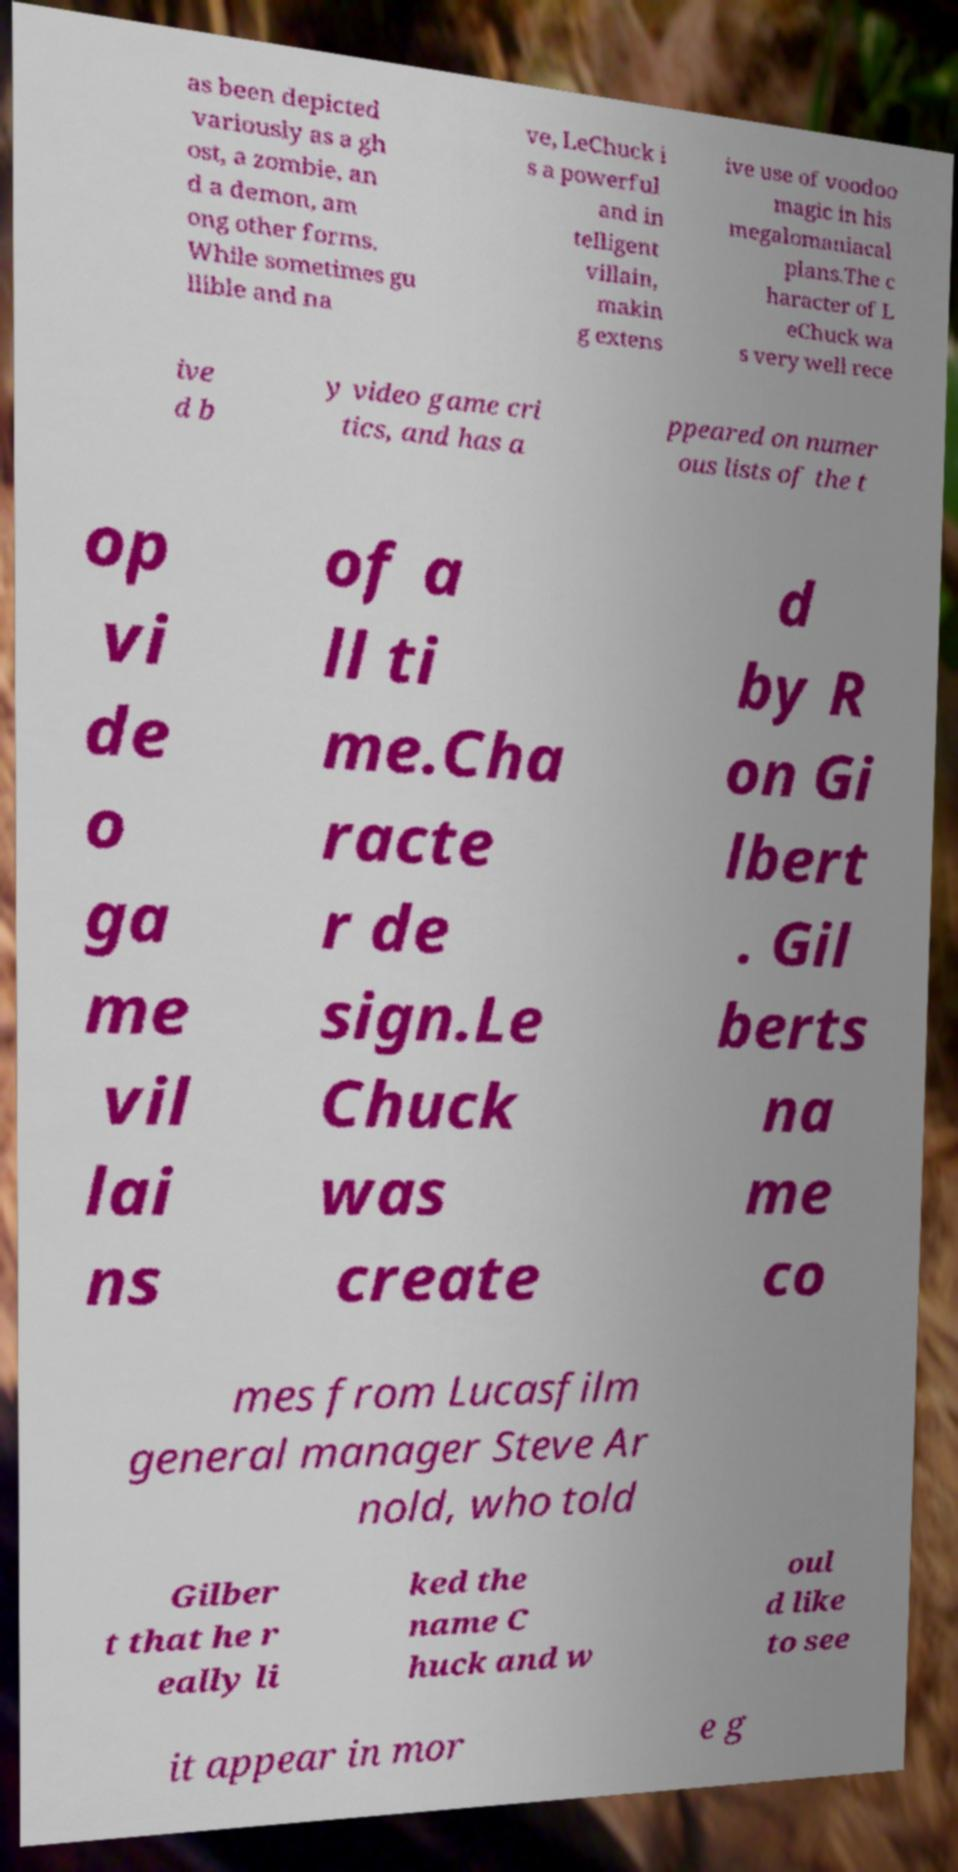There's text embedded in this image that I need extracted. Can you transcribe it verbatim? as been depicted variously as a gh ost, a zombie, an d a demon, am ong other forms. While sometimes gu llible and na ve, LeChuck i s a powerful and in telligent villain, makin g extens ive use of voodoo magic in his megalomaniacal plans.The c haracter of L eChuck wa s very well rece ive d b y video game cri tics, and has a ppeared on numer ous lists of the t op vi de o ga me vil lai ns of a ll ti me.Cha racte r de sign.Le Chuck was create d by R on Gi lbert . Gil berts na me co mes from Lucasfilm general manager Steve Ar nold, who told Gilber t that he r eally li ked the name C huck and w oul d like to see it appear in mor e g 